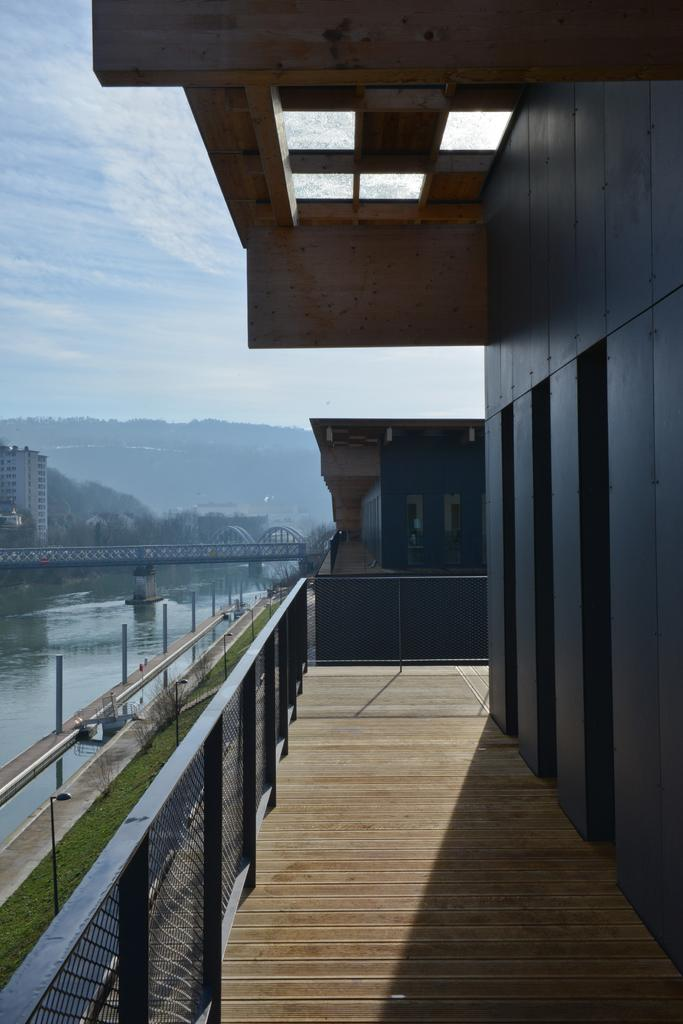What type of structures can be seen in the image? There are buildings in the image. What is above the water in the image? There is a bridge above the water in the image. What can be seen in the distance in the image? Mountains are visible in the background of the image. What is visible in the sky in the image? The sky is visible in the background of the image. Can you tell me how far the porter is from the battle in the image? There is no porter or battle present in the image. What type of distance is depicted between the mountains and the buildings in the image? The image does not provide information about the distance between the mountains and the buildings; it only shows their relative positions. 